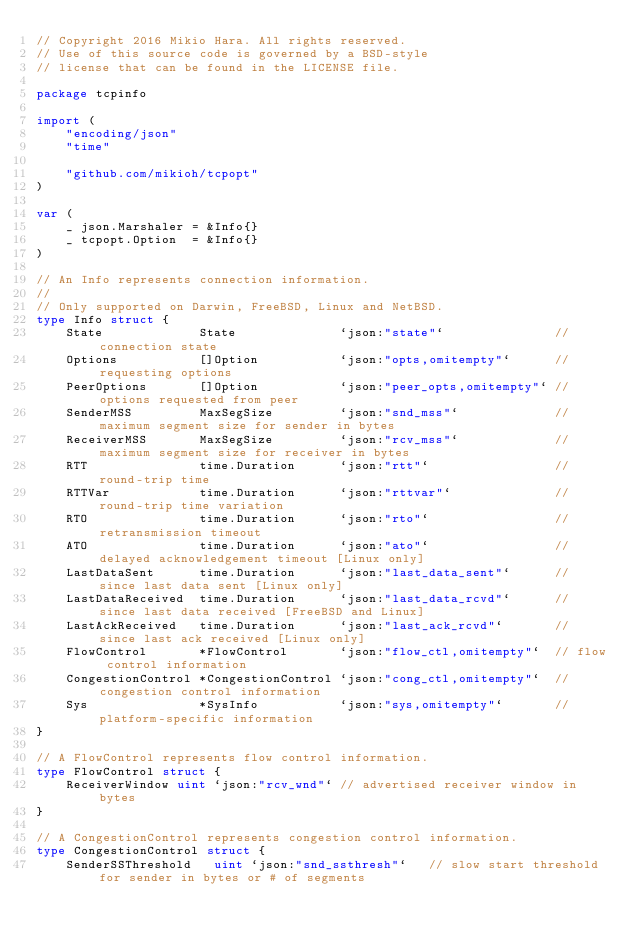Convert code to text. <code><loc_0><loc_0><loc_500><loc_500><_Go_>// Copyright 2016 Mikio Hara. All rights reserved.
// Use of this source code is governed by a BSD-style
// license that can be found in the LICENSE file.

package tcpinfo

import (
	"encoding/json"
	"time"

	"github.com/mikioh/tcpopt"
)

var (
	_ json.Marshaler = &Info{}
	_ tcpopt.Option  = &Info{}
)

// An Info represents connection information.
//
// Only supported on Darwin, FreeBSD, Linux and NetBSD.
type Info struct {
	State             State              `json:"state"`               // connection state
	Options           []Option           `json:"opts,omitempty"`      // requesting options
	PeerOptions       []Option           `json:"peer_opts,omitempty"` // options requested from peer
	SenderMSS         MaxSegSize         `json:"snd_mss"`             // maximum segment size for sender in bytes
	ReceiverMSS       MaxSegSize         `json:"rcv_mss"`             // maximum segment size for receiver in bytes
	RTT               time.Duration      `json:"rtt"`                 // round-trip time
	RTTVar            time.Duration      `json:"rttvar"`              // round-trip time variation
	RTO               time.Duration      `json:"rto"`                 // retransmission timeout
	ATO               time.Duration      `json:"ato"`                 // delayed acknowledgement timeout [Linux only]
	LastDataSent      time.Duration      `json:"last_data_sent"`      // since last data sent [Linux only]
	LastDataReceived  time.Duration      `json:"last_data_rcvd"`      // since last data received [FreeBSD and Linux]
	LastAckReceived   time.Duration      `json:"last_ack_rcvd"`       // since last ack received [Linux only]
	FlowControl       *FlowControl       `json:"flow_ctl,omitempty"`  // flow control information
	CongestionControl *CongestionControl `json:"cong_ctl,omitempty"`  // congestion control information
	Sys               *SysInfo           `json:"sys,omitempty"`       // platform-specific information
}

// A FlowControl represents flow control information.
type FlowControl struct {
	ReceiverWindow uint `json:"rcv_wnd"` // advertised receiver window in bytes
}

// A CongestionControl represents congestion control information.
type CongestionControl struct {
	SenderSSThreshold   uint `json:"snd_ssthresh"`   // slow start threshold for sender in bytes or # of segments</code> 